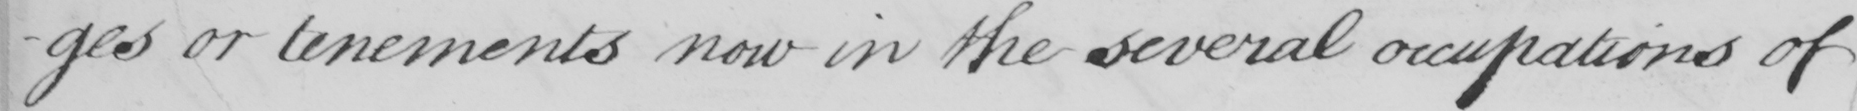What text is written in this handwritten line? -ges or tenements now in the several occupations of 